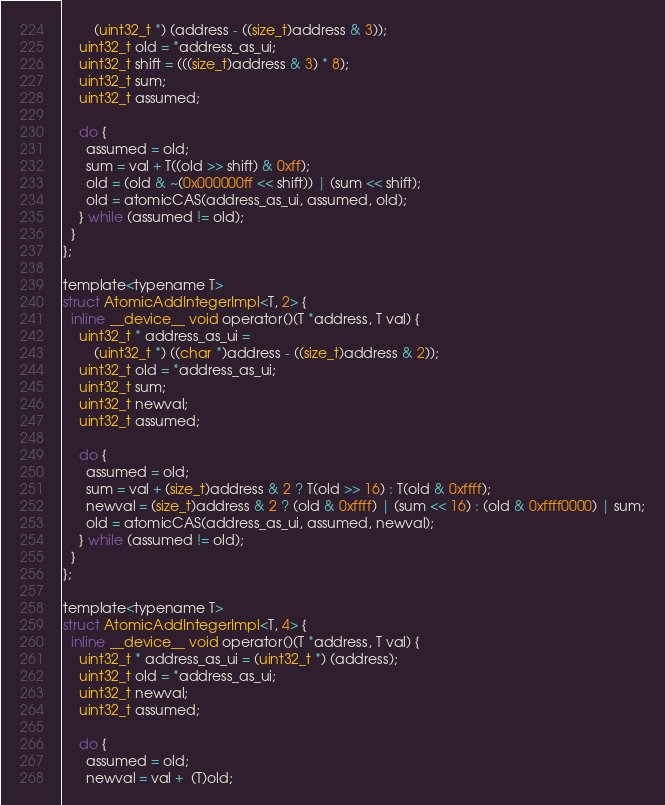Convert code to text. <code><loc_0><loc_0><loc_500><loc_500><_Cuda_>        (uint32_t *) (address - ((size_t)address & 3));
    uint32_t old = *address_as_ui;
    uint32_t shift = (((size_t)address & 3) * 8);
    uint32_t sum;
    uint32_t assumed;

    do {
      assumed = old;
      sum = val + T((old >> shift) & 0xff);
      old = (old & ~(0x000000ff << shift)) | (sum << shift);
      old = atomicCAS(address_as_ui, assumed, old);
    } while (assumed != old);
  }
};

template<typename T>
struct AtomicAddIntegerImpl<T, 2> {
  inline __device__ void operator()(T *address, T val) {
    uint32_t * address_as_ui =
        (uint32_t *) ((char *)address - ((size_t)address & 2));
    uint32_t old = *address_as_ui;
    uint32_t sum;
    uint32_t newval;
    uint32_t assumed;

    do {
      assumed = old;
      sum = val + (size_t)address & 2 ? T(old >> 16) : T(old & 0xffff);
      newval = (size_t)address & 2 ? (old & 0xffff) | (sum << 16) : (old & 0xffff0000) | sum;
      old = atomicCAS(address_as_ui, assumed, newval);
    } while (assumed != old);
  }
};

template<typename T>
struct AtomicAddIntegerImpl<T, 4> {
  inline __device__ void operator()(T *address, T val) {
    uint32_t * address_as_ui = (uint32_t *) (address);
    uint32_t old = *address_as_ui;
    uint32_t newval;
    uint32_t assumed;

    do {
      assumed = old;
      newval = val +  (T)old;</code> 